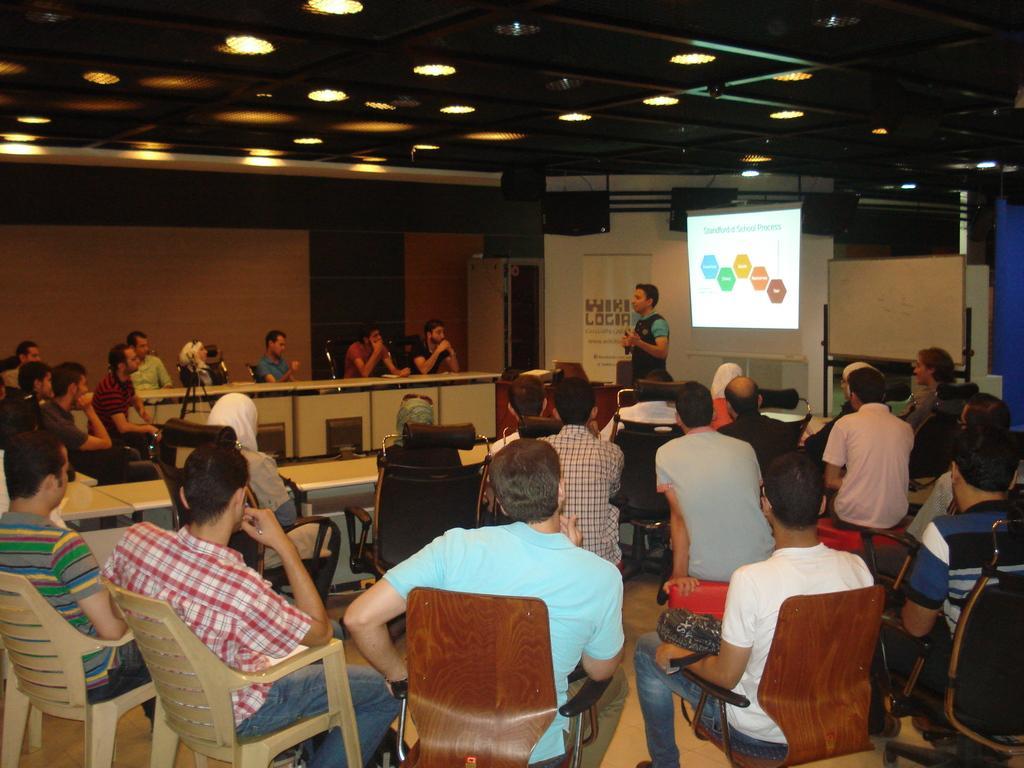How would you summarize this image in a sentence or two? In this picture a guy is explaining with a projector screen behind him. There are many people sitting and listening to them. The picture is clicked inside the conference hall. 